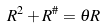Convert formula to latex. <formula><loc_0><loc_0><loc_500><loc_500>R ^ { 2 } + R ^ { \# } = \theta R</formula> 